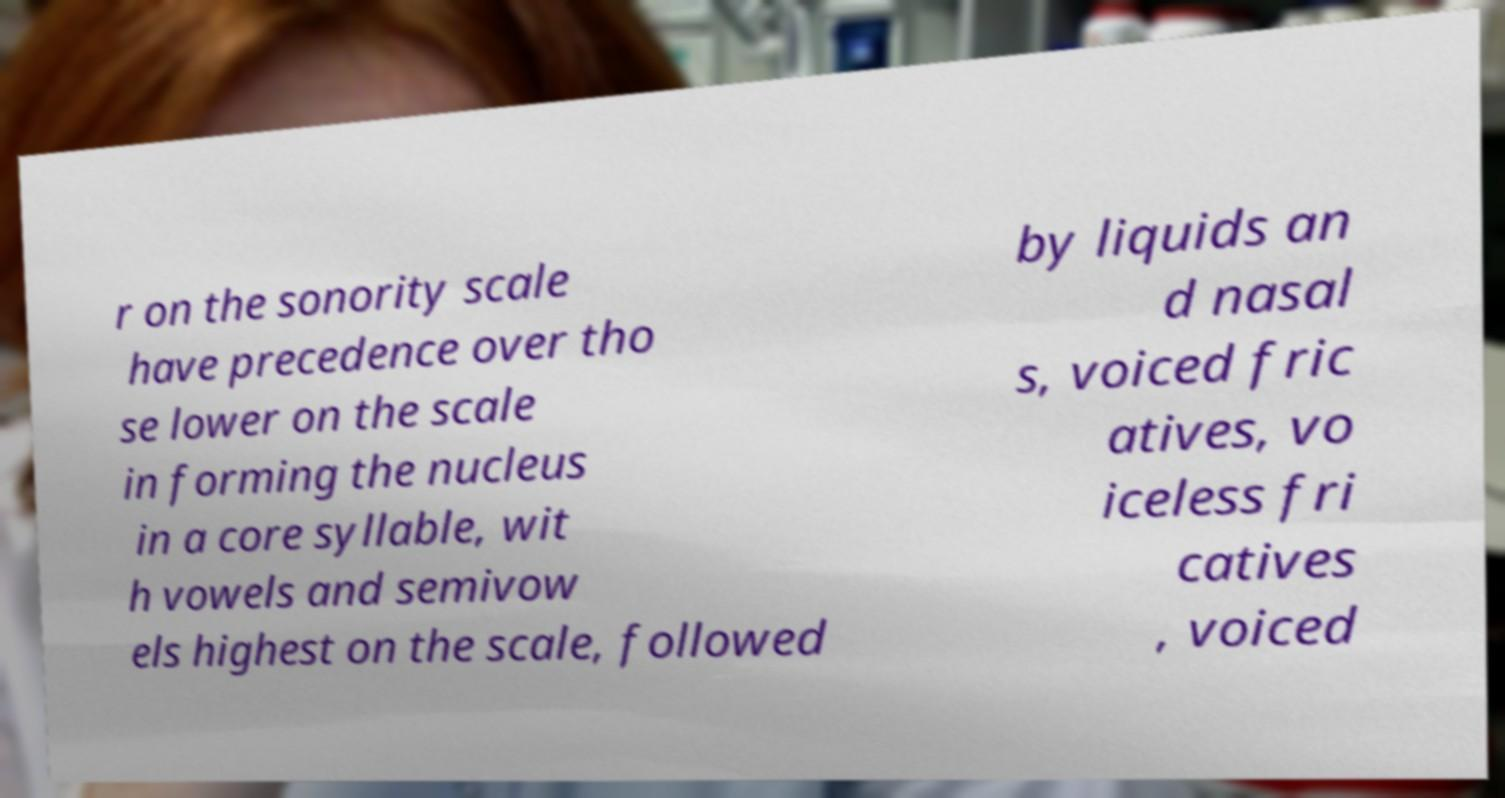Could you assist in decoding the text presented in this image and type it out clearly? r on the sonority scale have precedence over tho se lower on the scale in forming the nucleus in a core syllable, wit h vowels and semivow els highest on the scale, followed by liquids an d nasal s, voiced fric atives, vo iceless fri catives , voiced 